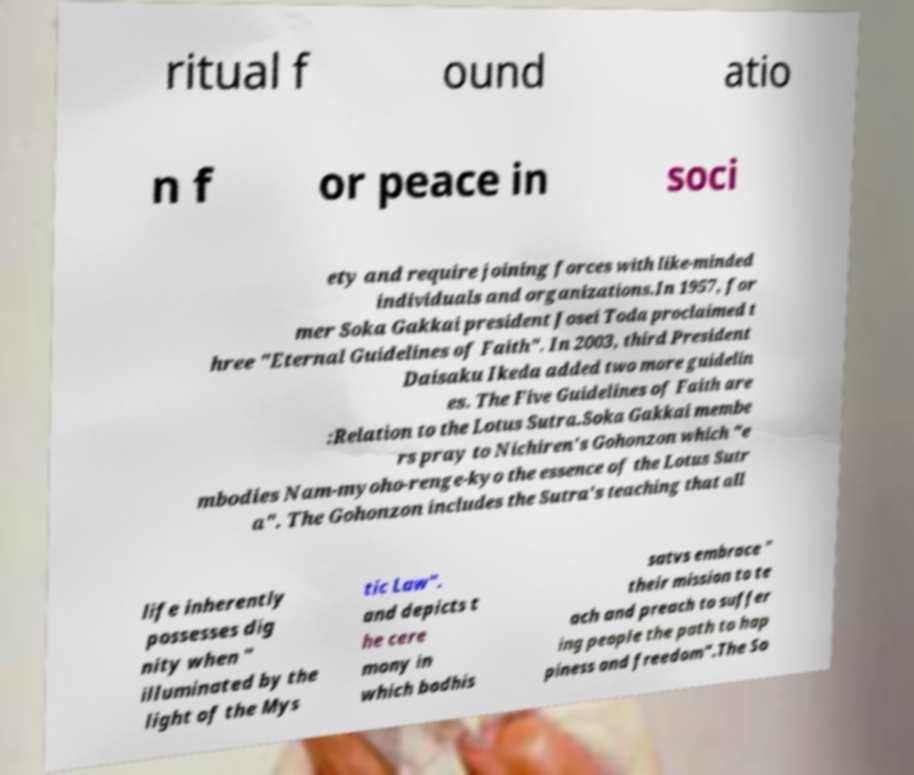Can you accurately transcribe the text from the provided image for me? ritual f ound atio n f or peace in soci ety and require joining forces with like-minded individuals and organizations.In 1957, for mer Soka Gakkai president Josei Toda proclaimed t hree "Eternal Guidelines of Faith". In 2003, third President Daisaku Ikeda added two more guidelin es. The Five Guidelines of Faith are :Relation to the Lotus Sutra.Soka Gakkai membe rs pray to Nichiren's Gohonzon which "e mbodies Nam-myoho-renge-kyo the essence of the Lotus Sutr a". The Gohonzon includes the Sutra's teaching that all life inherently possesses dig nity when " illuminated by the light of the Mys tic Law". and depicts t he cere mony in which bodhis satvs embrace " their mission to te ach and preach to suffer ing people the path to hap piness and freedom".The So 